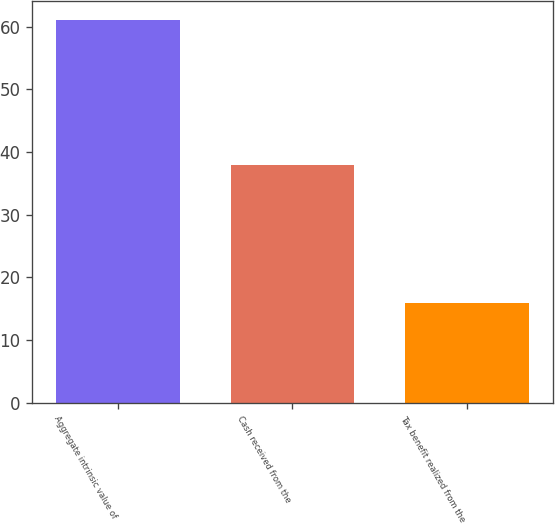Convert chart to OTSL. <chart><loc_0><loc_0><loc_500><loc_500><bar_chart><fcel>Aggregate intrinsic value of<fcel>Cash received from the<fcel>Tax benefit realized from the<nl><fcel>61<fcel>38<fcel>16<nl></chart> 